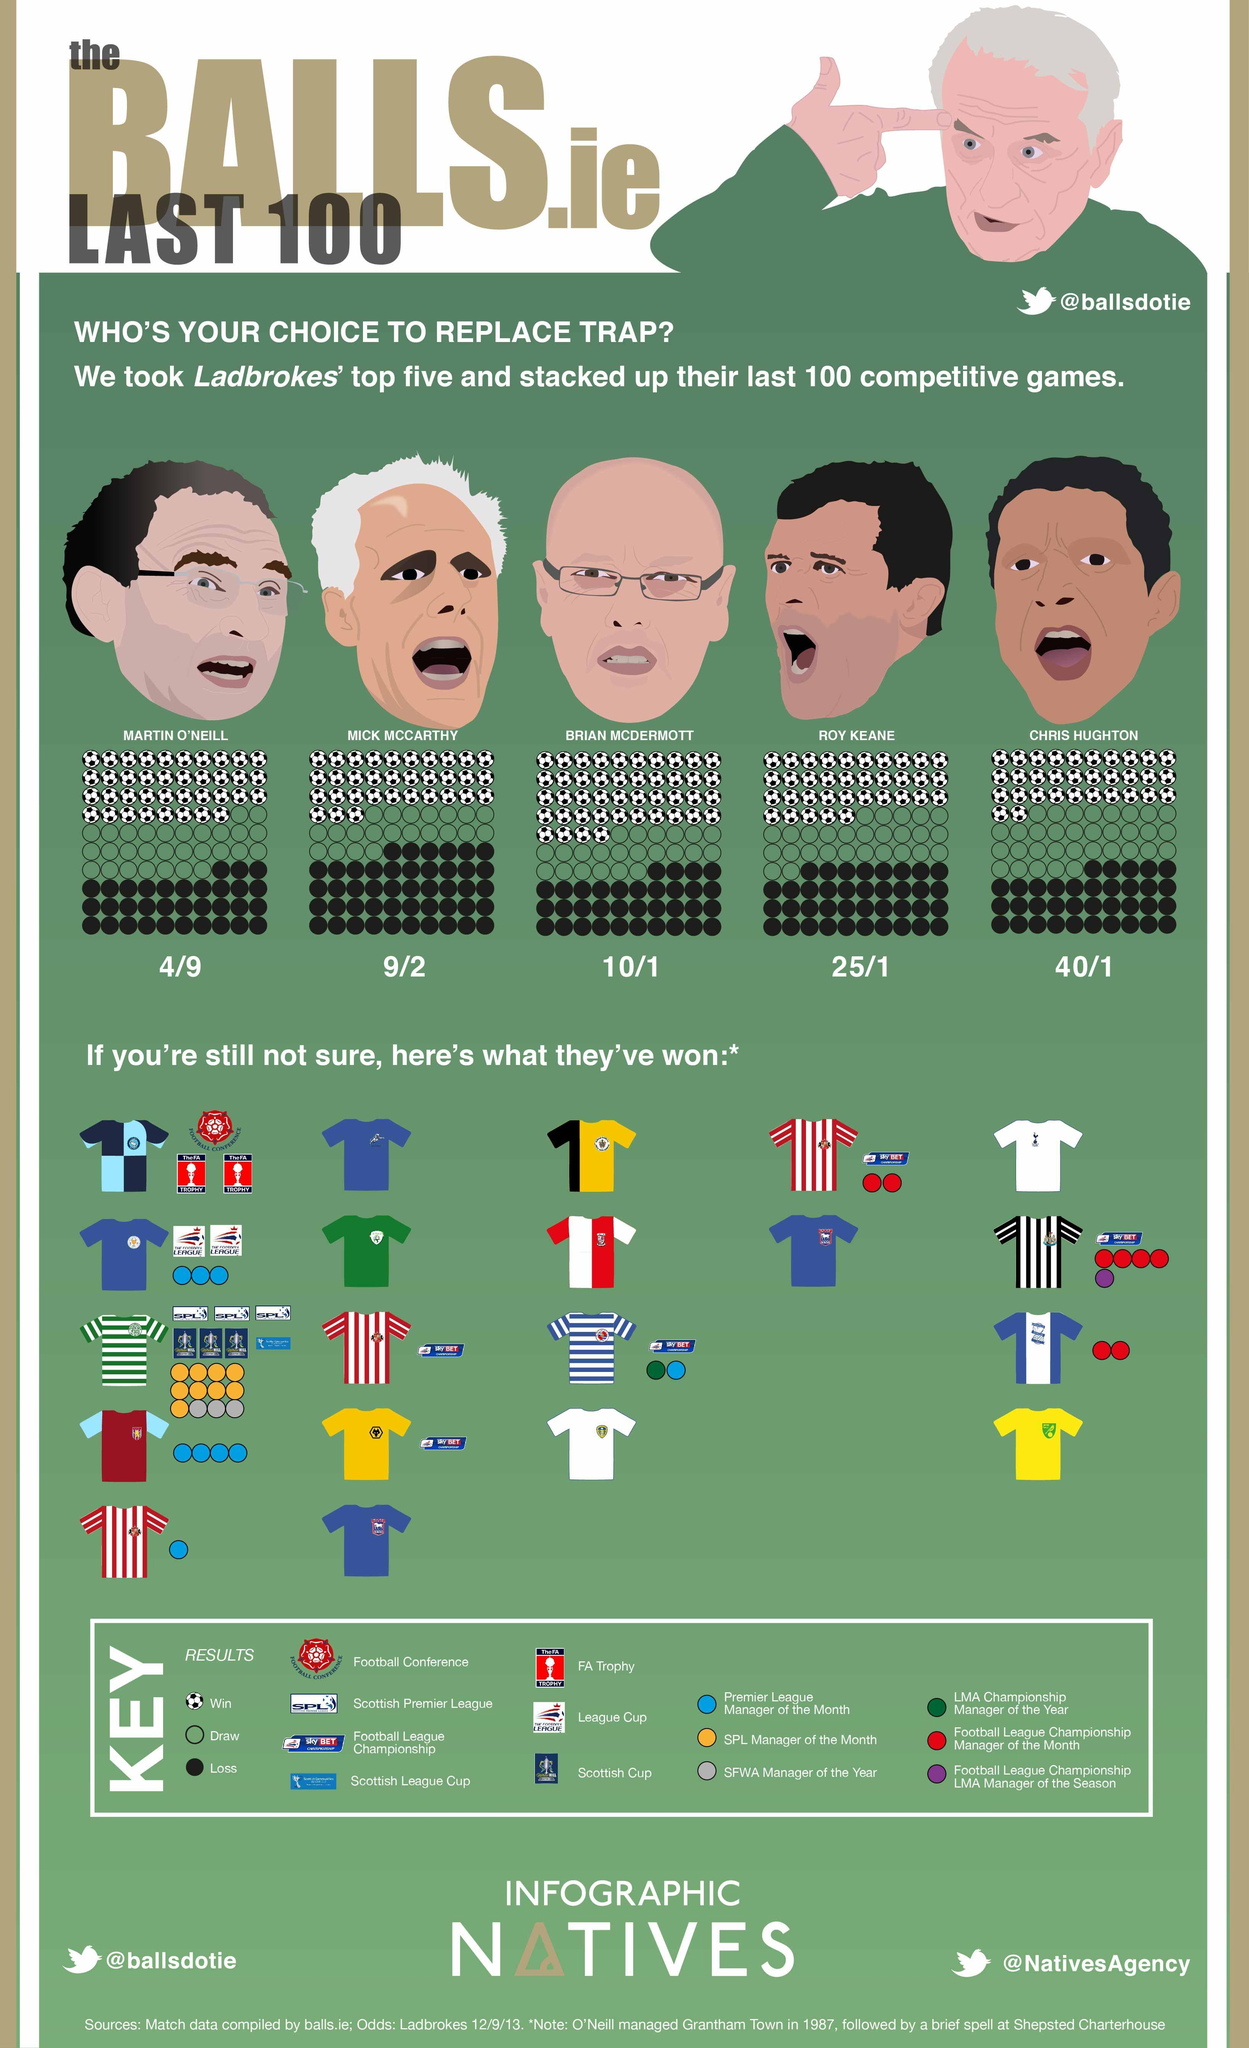How many jerseys are shown in the infographic?
Answer the question with a short phrase. 20 How many jerseys shown have yellow colour on them? 3 What are the names of the men wearing spectacles? MARTIN O'NEILL, BRIAN MCDERMOTT What is the name of the bald person wearing spectacles? BRIAN MCDERMOTT How many different Twitter handles are given? 2 How many men shown have white or grey hair? 2 How many faces are shown in the infographic? 6 By what colour is Premier League Manager of the Month represented- yellow, blue or red? blue What does the yellow coloured circle in the KEY denote? SPL Manager of the Month By what colour is Loss represented- white or black? black How many soccer balls are shown under Roy Keane? 35 What are the Twitter handles given? @ballsdotie, @NativesAgency How many horizontally striped jerseys are shown? 2 What does the soccer ball represent? Win 